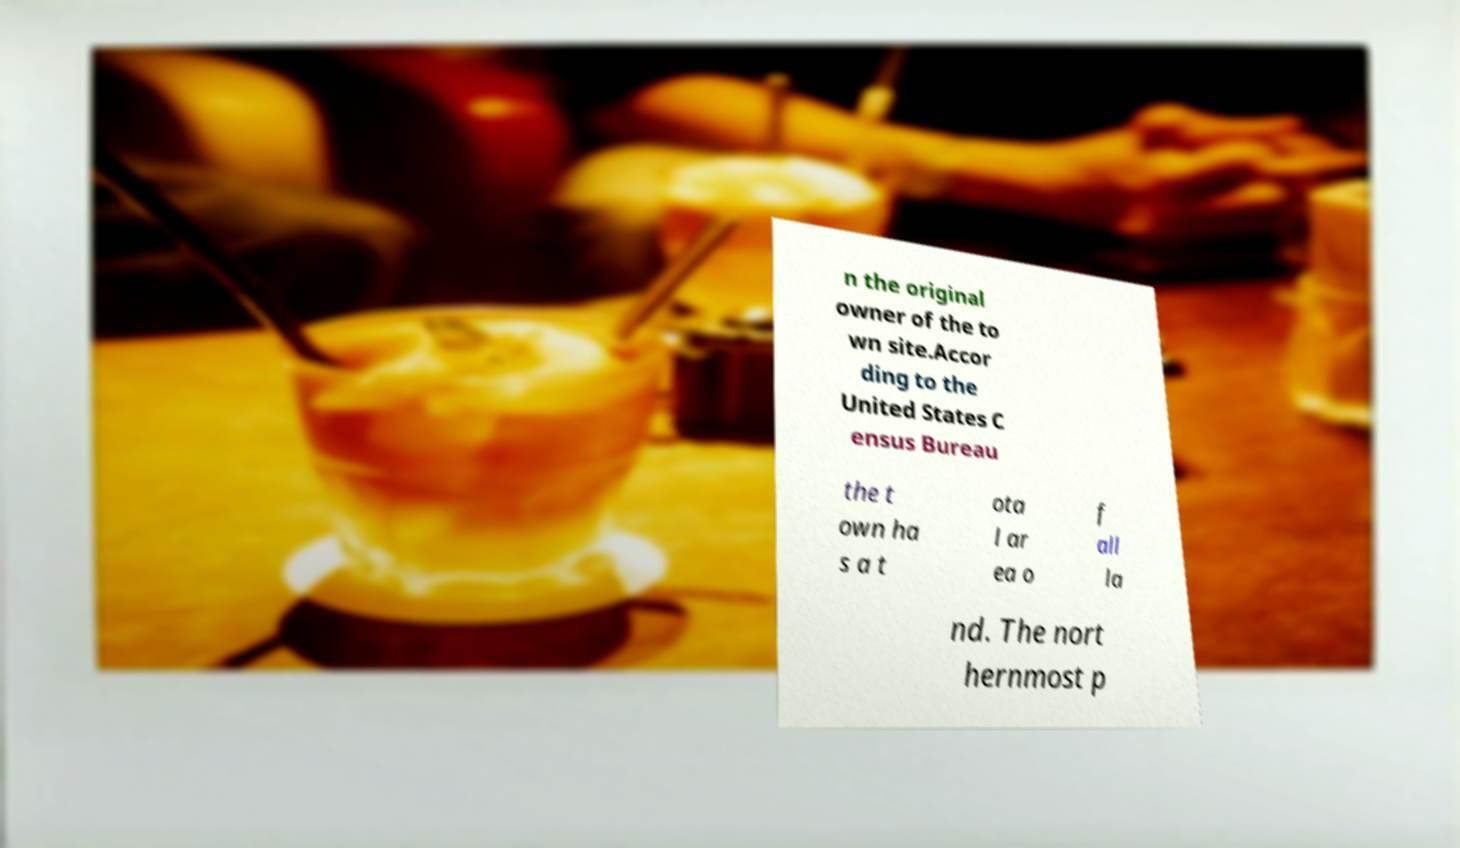Could you extract and type out the text from this image? n the original owner of the to wn site.Accor ding to the United States C ensus Bureau the t own ha s a t ota l ar ea o f all la nd. The nort hernmost p 